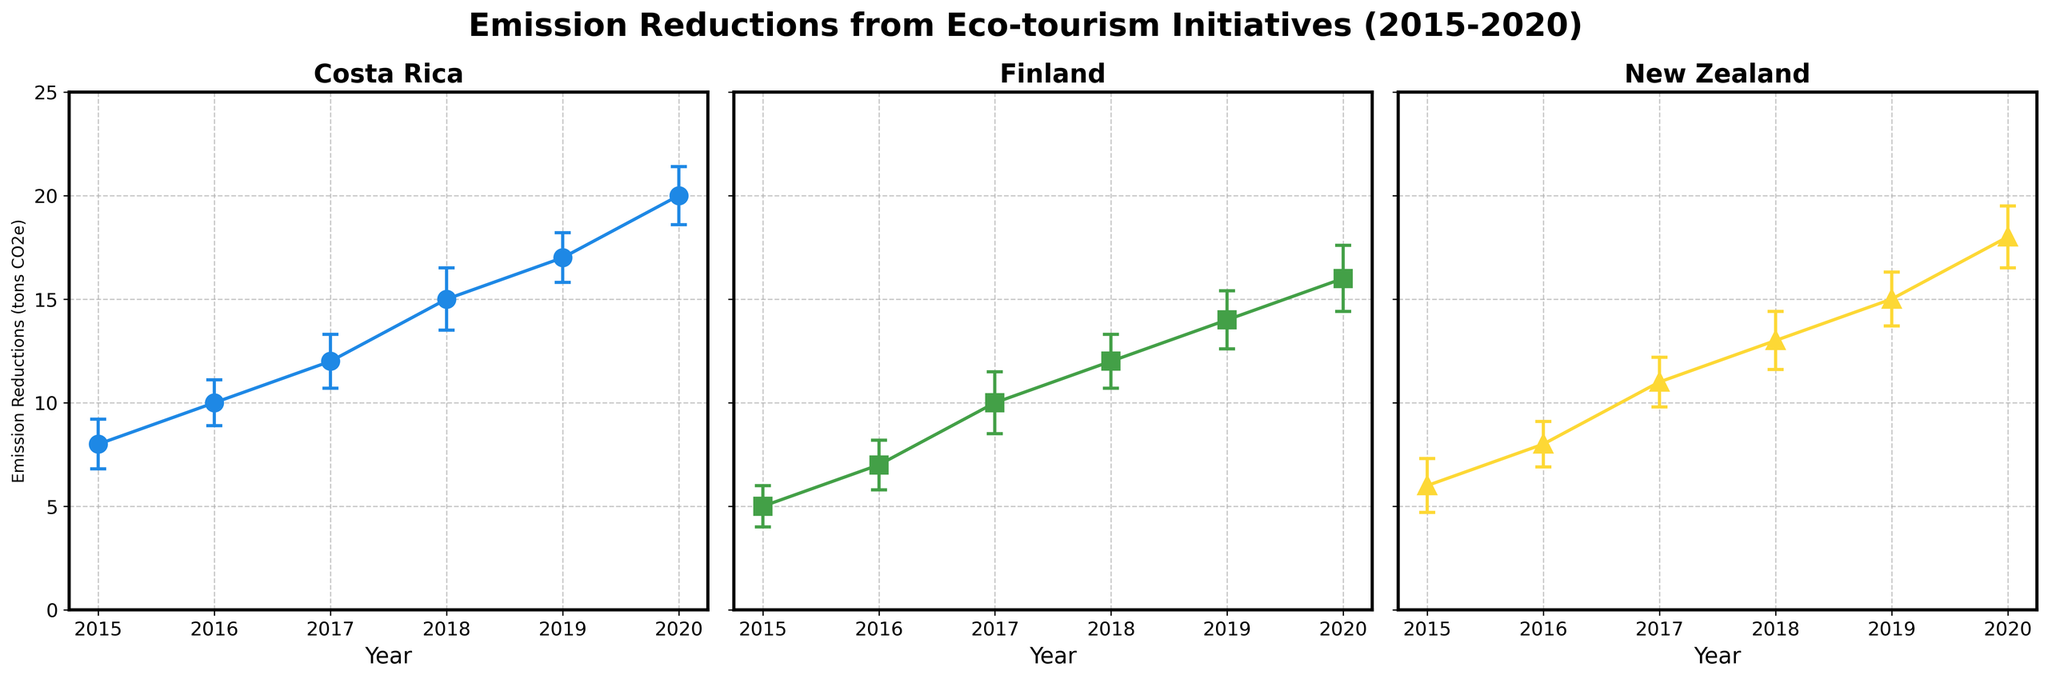What is the title of the figure? The title of a figure typically describes what the data represents. It is located at the top and helps provide context for the viewer. In this figure, the title given at the top is "Emission Reductions from Eco-tourism Initiatives (2015-2020)."
Answer: Emission Reductions from Eco-tourism Initiatives (2015-2020) How many subplots are present in the figure? The number of subplots can be determined by quickly scanning the entire figure and counting the number of individual plots. There are three distinct subplots, each representing a different country.
Answer: 3 Which year did Costa Rica have the highest emission reductions? Look at Costa Rica's subplot and compare the emission reduction values for each year. The highest value is found in the year 2020 with an emission reduction of 20 tons CO2e.
Answer: 2020 What is the error value for Finland in 2017? Locate Finland's subplot and look for the data point representing the year 2017. The vertical line (error bar) indicates the level of uncertainty, and it is shown that the error value for Finland in 2017 is 1.5.
Answer: 1.5 Which country had the least emission reductions in 2015? To answer this, compare the emission reduction values for the year 2015 across all three subplots. Costa Rica had 8, Finland had 5, and New Zealand had 6, making Finland the country with the least emission reduction in 2015.
Answer: Finland What is the difference in emission reductions between New Zealand and Finland in 2020? Check the emission reduction values for both countries in the year 2020. New Zealand's value is 18, and Finland's value is 16. The difference is calculated as 18 - 16 = 2 tons CO2e.
Answer: 2 Based on the subplots, which country has shown a more consistent increase in emission reductions over the given years? To determine consistency, observe the trend lines for all three countries. New Zealand shows a relatively steady and consistent increase in emission reduction from 2015 to 2020, more smooth than the other two countries.
Answer: New Zealand What is the combined emission reduction for Costa Rica and Finland in 2019? Sum the emission reductions for both countries in 2019. Costa Rica has 17 tons, and Finland has 14 tons; their combined emission reduction is 17 + 14 = 31 tons CO2e.
Answer: 31 For which year is the error margin smallest across all countries? Check each year across all subplots and compare the error values. In 2016, Costa Rica's error is 1.1, Finland's error is 1.2, and New Zealand's error is 1.1. The smallest error value is 1.1, which occurs in Costa Rica and New Zealand in 2016.
Answer: 2016 